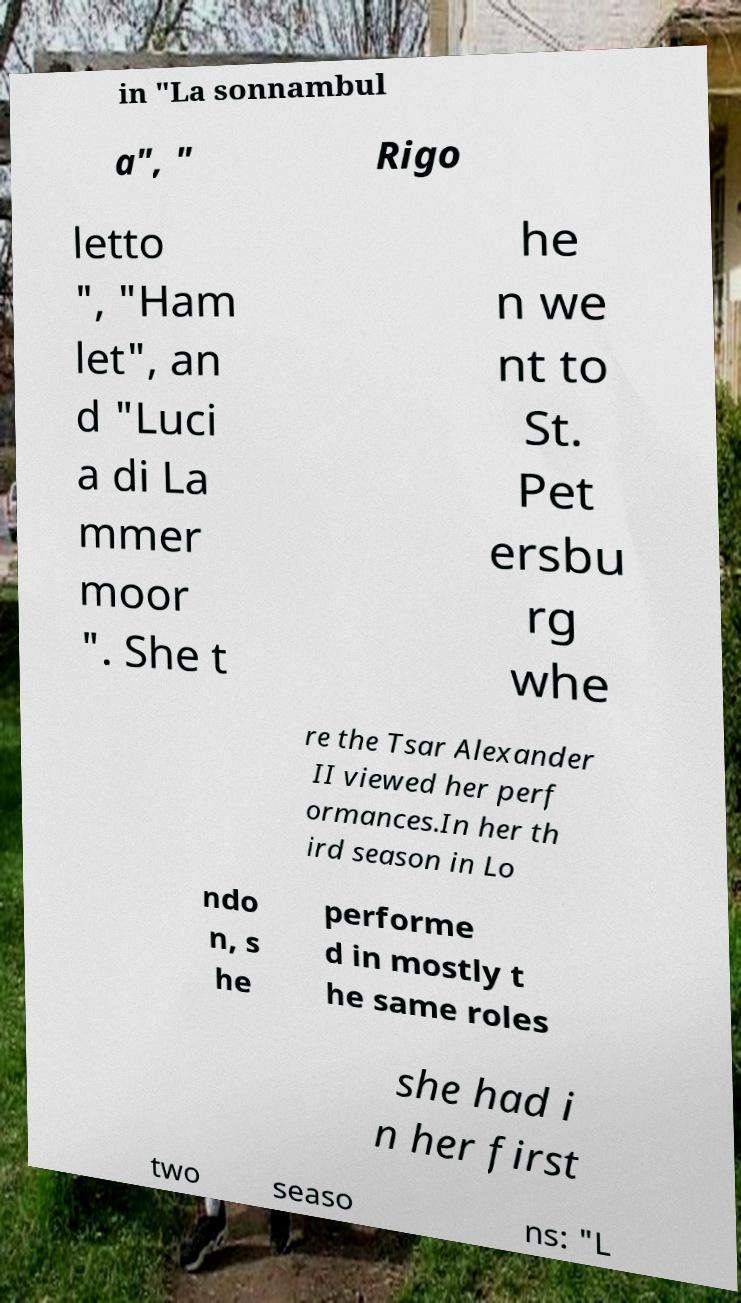Please read and relay the text visible in this image. What does it say? in "La sonnambul a", " Rigo letto ", "Ham let", an d "Luci a di La mmer moor ". She t he n we nt to St. Pet ersbu rg whe re the Tsar Alexander II viewed her perf ormances.In her th ird season in Lo ndo n, s he performe d in mostly t he same roles she had i n her first two seaso ns: "L 